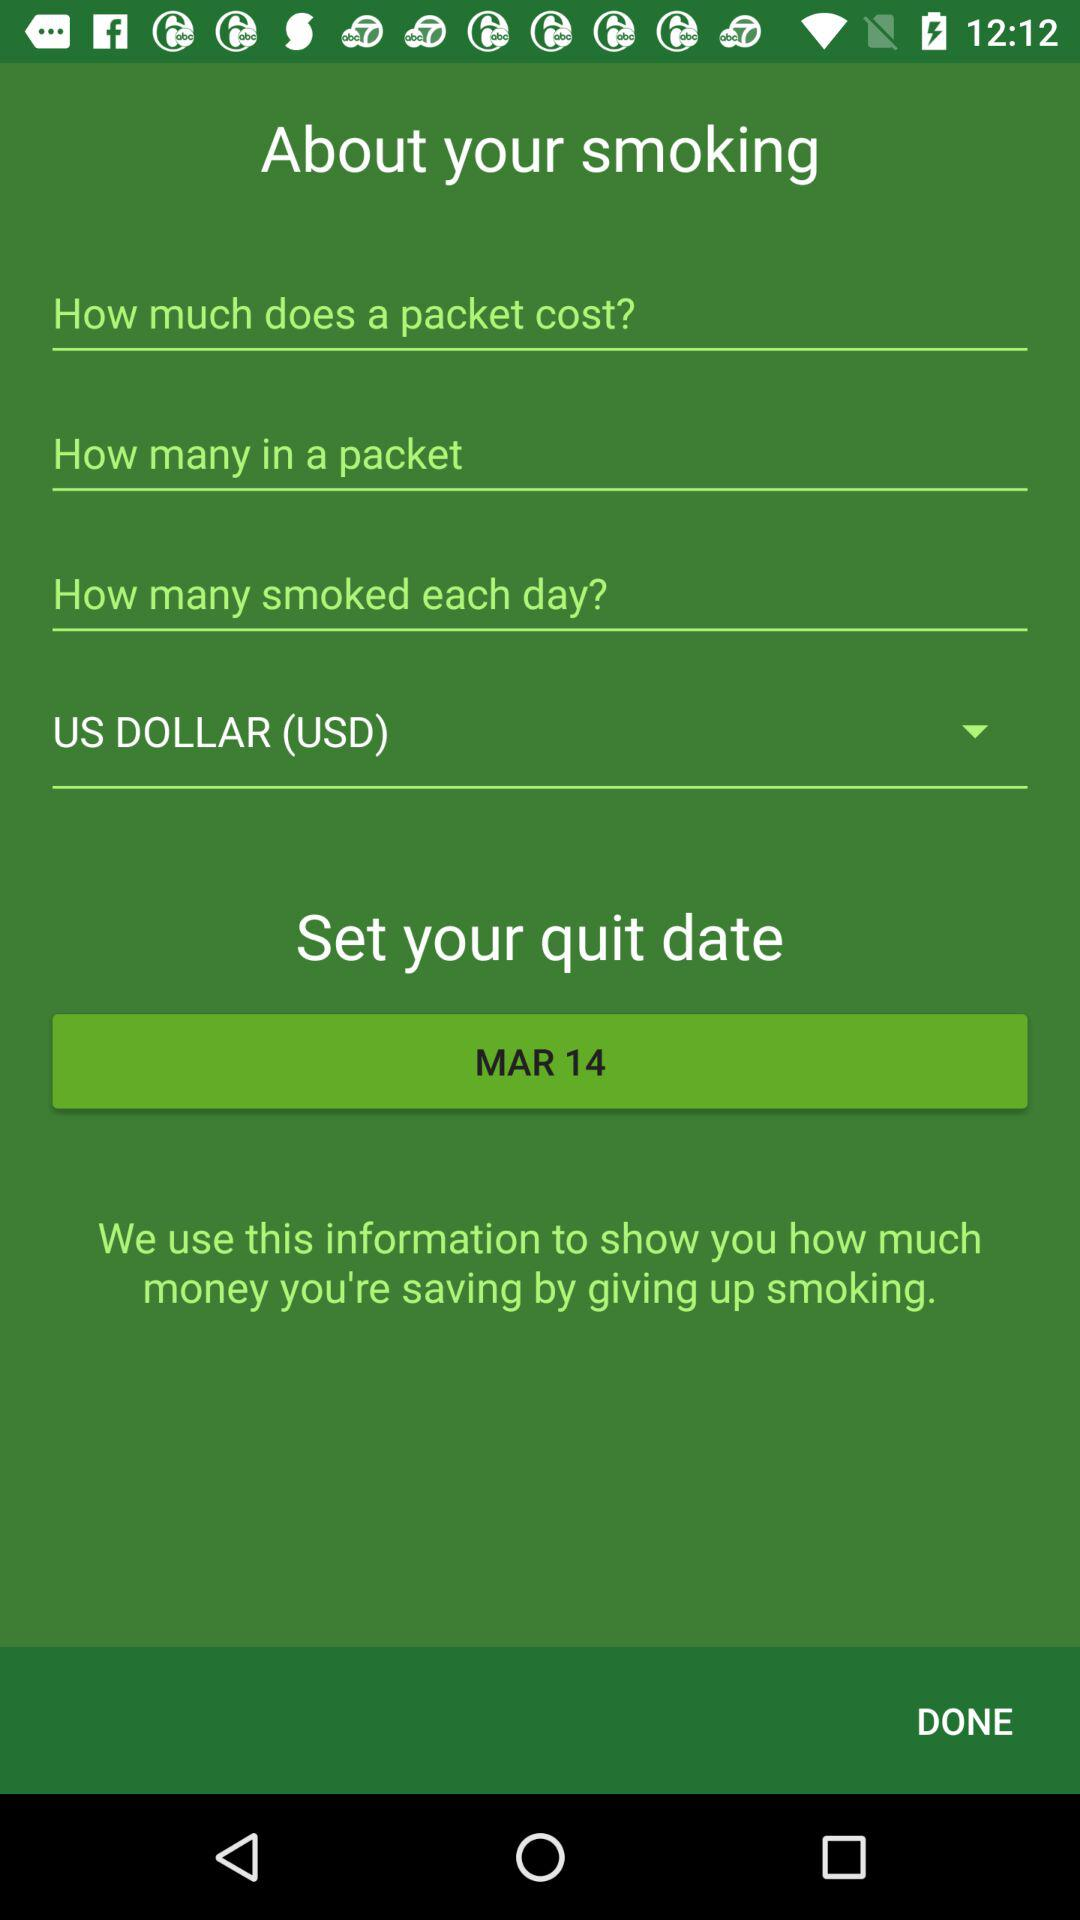What's the selected currency? The selected currency is the US dollar. 